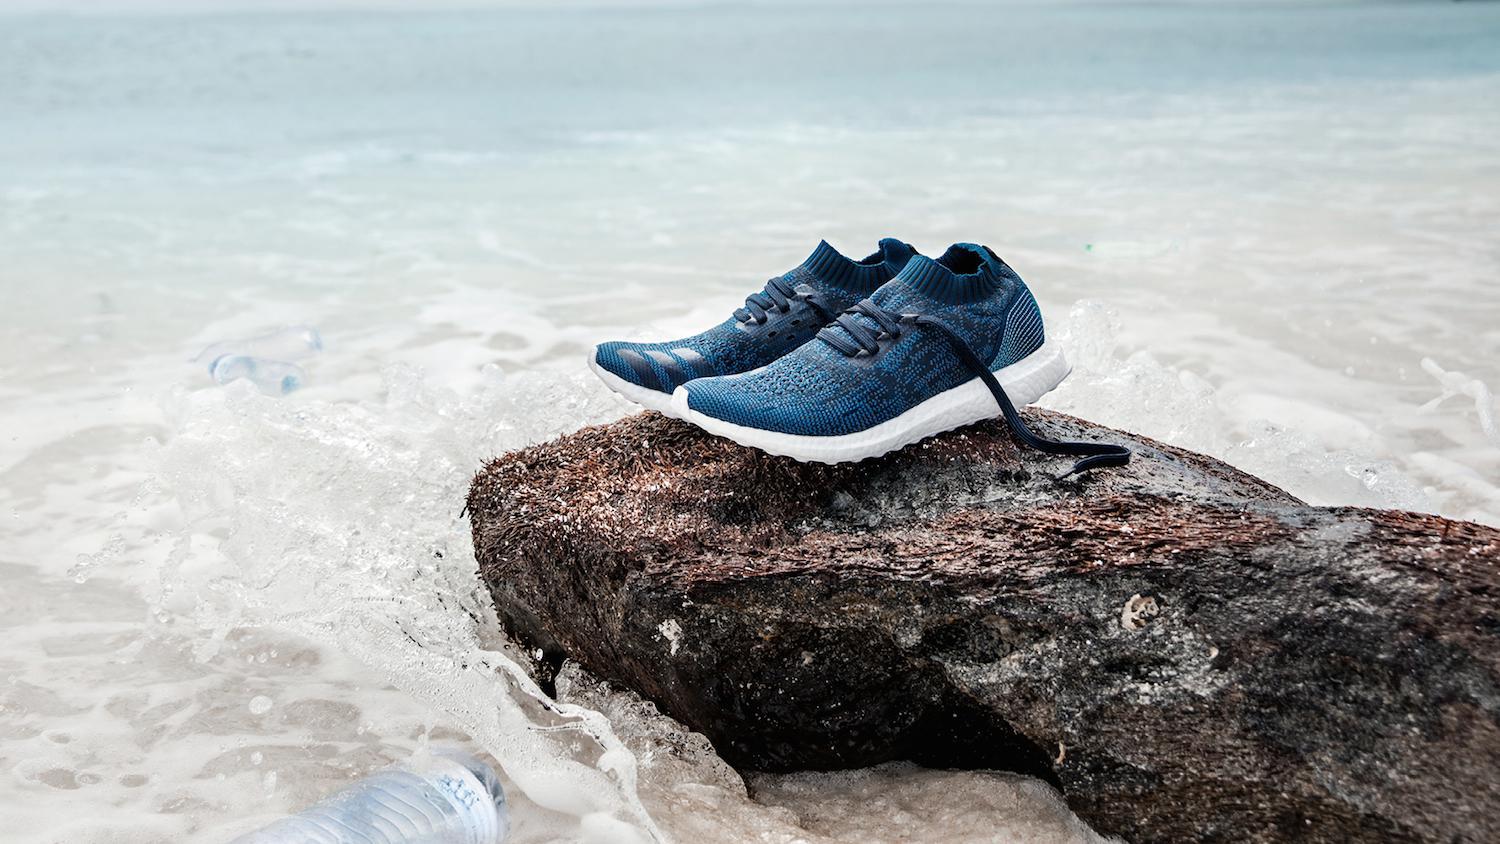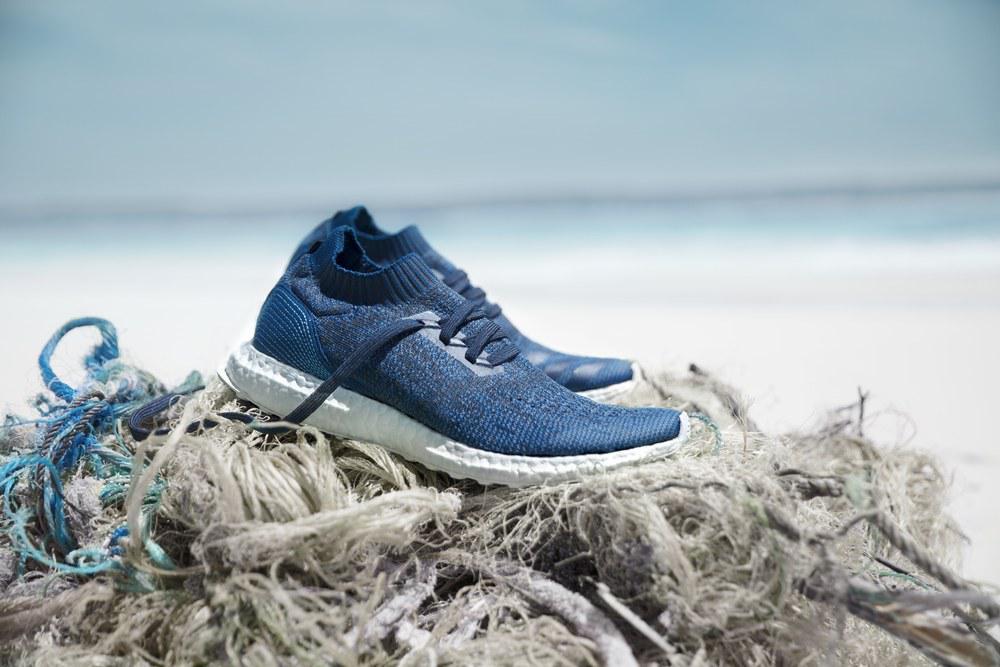The first image is the image on the left, the second image is the image on the right. Given the left and right images, does the statement "An image shows blue sneakers posed with a tangle of fibrous strings." hold true? Answer yes or no. Yes. The first image is the image on the left, the second image is the image on the right. Analyze the images presented: Is the assertion "There are more than three shoes." valid? Answer yes or no. Yes. 